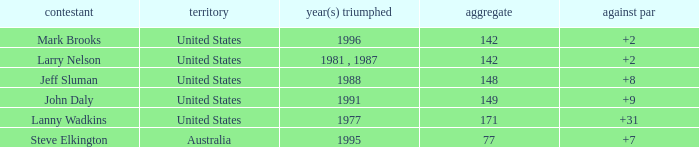Name the Total of australia and a To par smaller than 7? None. 